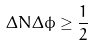Convert formula to latex. <formula><loc_0><loc_0><loc_500><loc_500>\Delta N \Delta \phi \geq \frac { 1 } { 2 }</formula> 